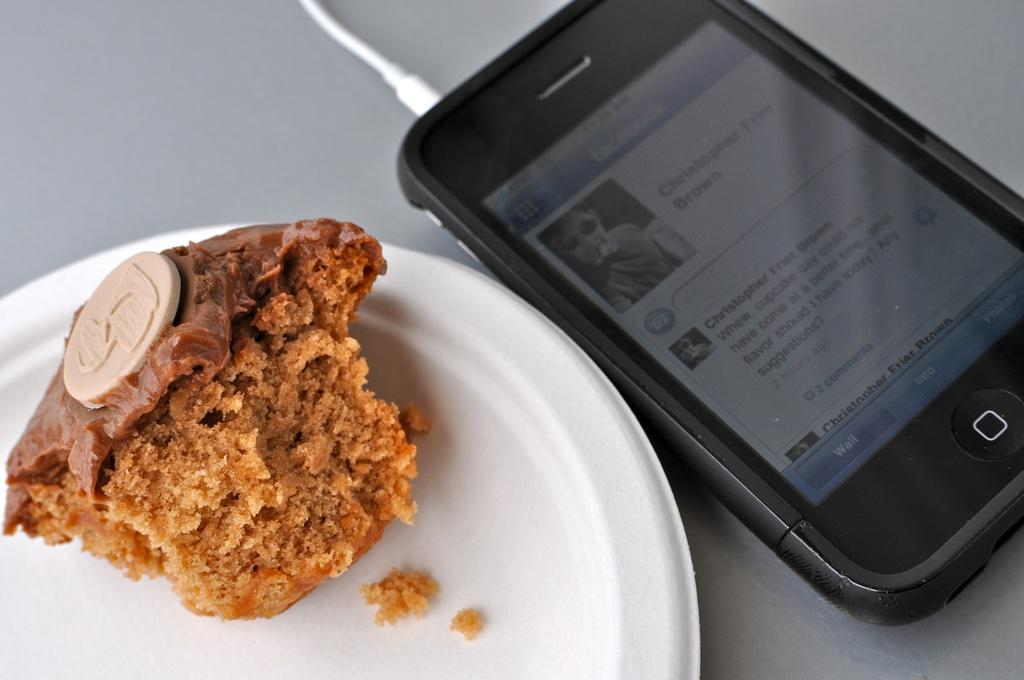What is the main object in the image? There is a mobile in the image. What is connected to the mobile? There is a cable in the image. What else can be seen on the surface where the mobile and cable are present? There is a plate containing food in the image. On what type of surface are these objects placed? The objects are present on a surface. What type of coast can be seen in the image? There is no coast present in the image. Is the queen visible in the image? There is no queen present in the image. 